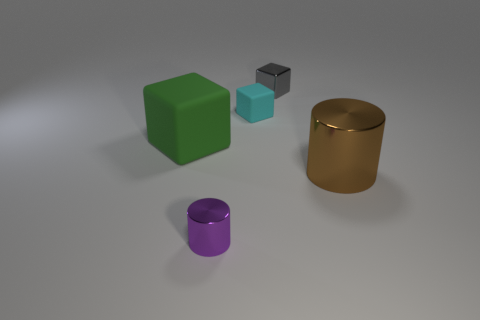If these objects were part of a game, what sort of game do you think it might be? If these objects were a part of a game, it could be a physical puzzle or strategy game, where each object has to be placed in a specific position or order to achieve balance or complete a pattern or sequence, given their different shapes and colors. 